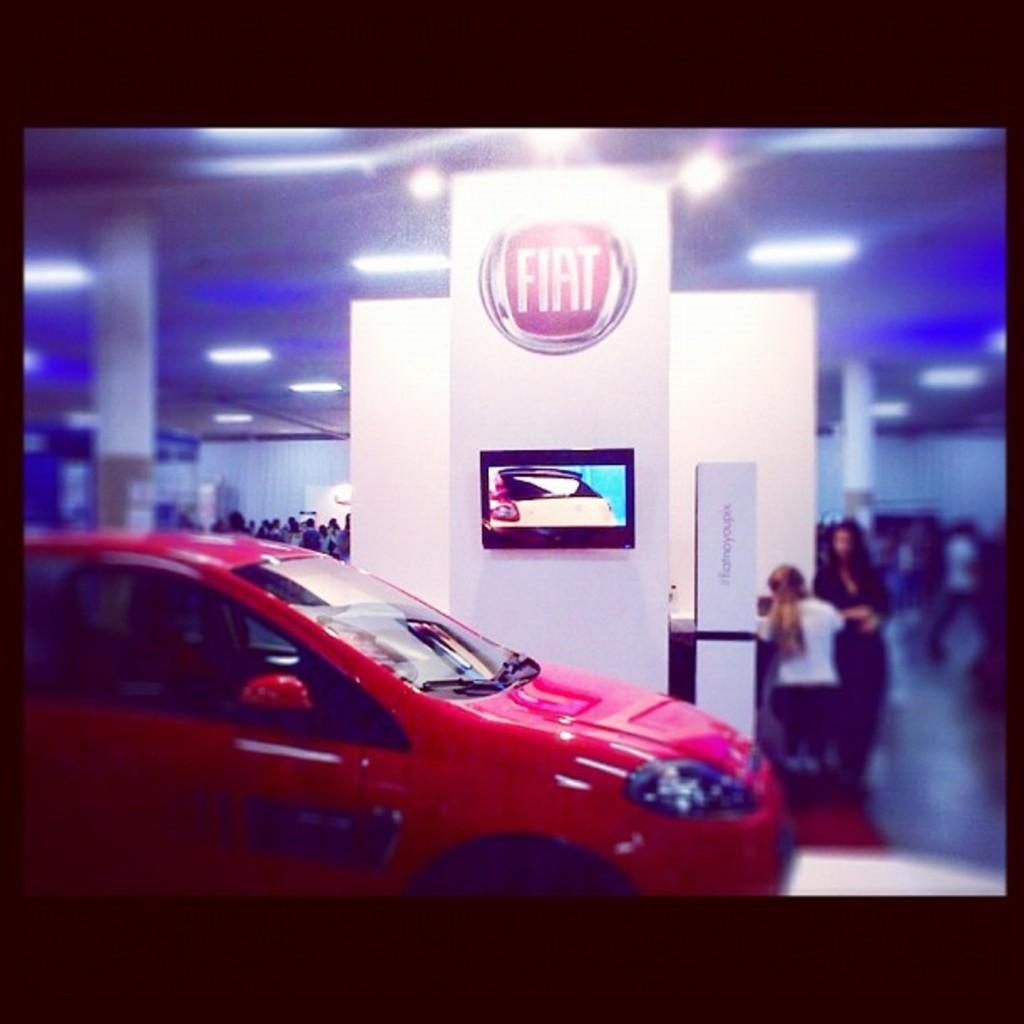What type of vehicle is in the image? There is a red car in the image. What can be seen in the background of the image? There are pillars and TVs in the background of the image. Are there any people visible in the image? Yes, there are people standing in the background of the image near the wall. What type of camp can be seen in the image? There is no camp present in the image. Can you see an airplane in the image? No, there is no airplane visible in the image. 